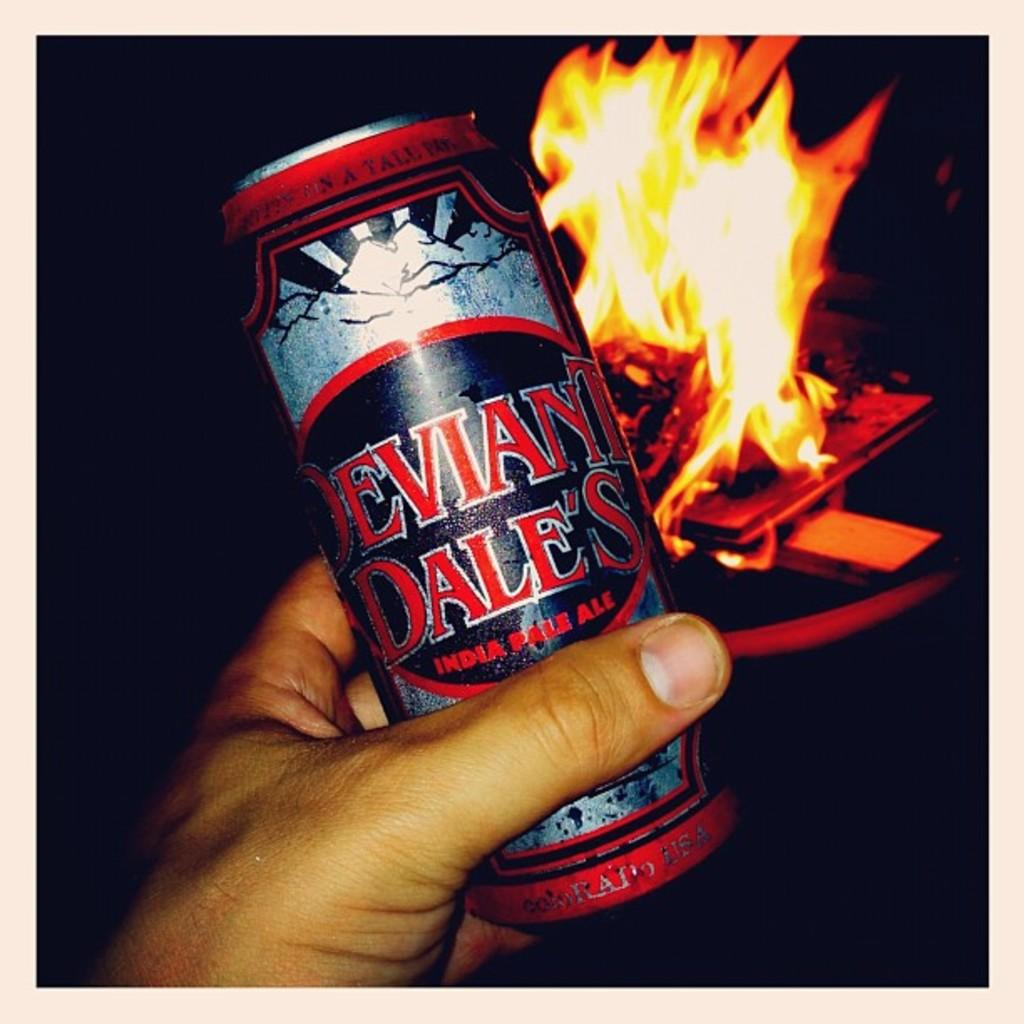<image>
Render a clear and concise summary of the photo. A person is holding a can of Deviant Dale's in front of a camp fire. 